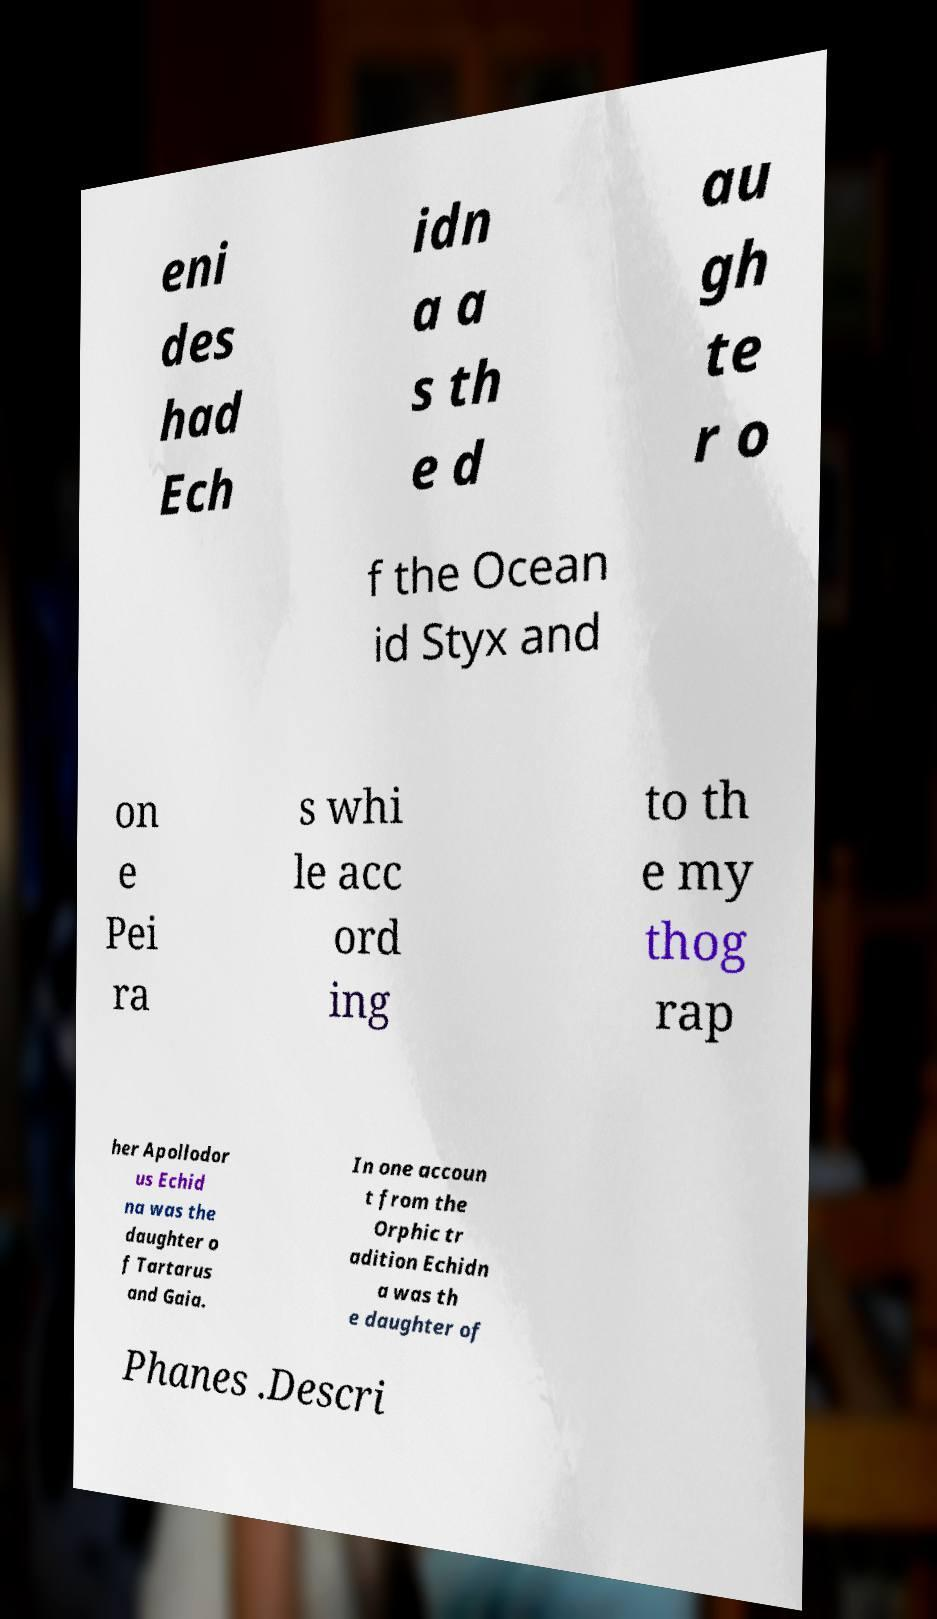Can you accurately transcribe the text from the provided image for me? eni des had Ech idn a a s th e d au gh te r o f the Ocean id Styx and on e Pei ra s whi le acc ord ing to th e my thog rap her Apollodor us Echid na was the daughter o f Tartarus and Gaia. In one accoun t from the Orphic tr adition Echidn a was th e daughter of Phanes .Descri 